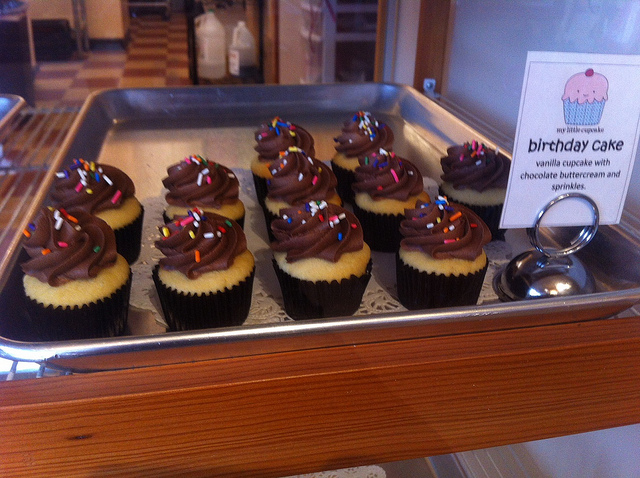Please transcribe the text in this image. birthday cake and cupcale chocolate sprinkles buffercream 